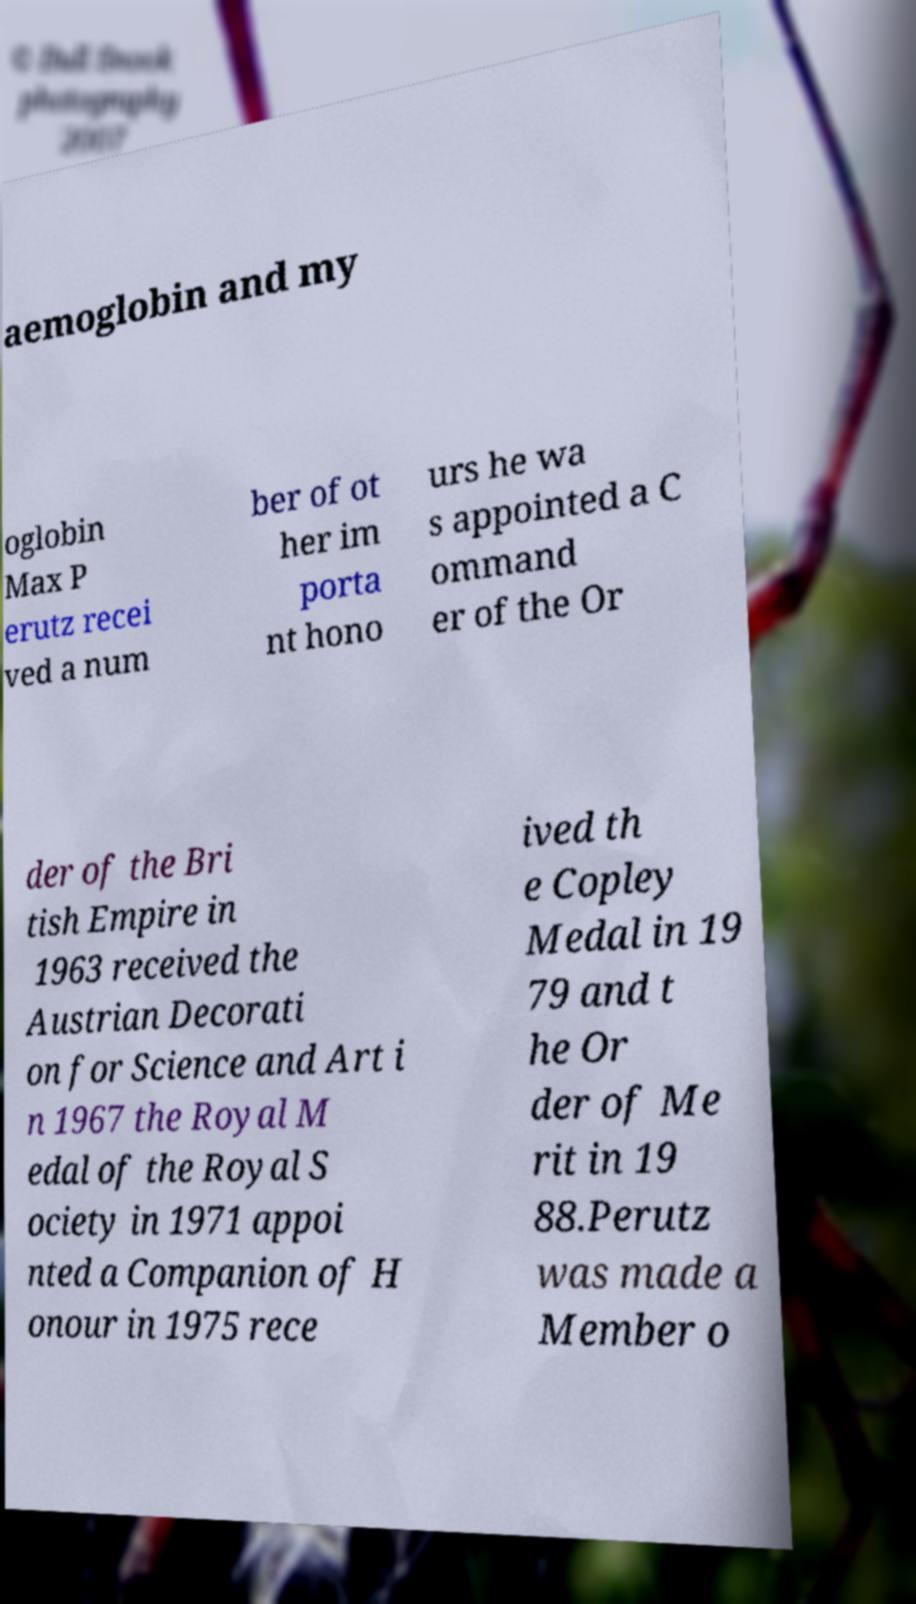Can you read and provide the text displayed in the image?This photo seems to have some interesting text. Can you extract and type it out for me? aemoglobin and my oglobin Max P erutz recei ved a num ber of ot her im porta nt hono urs he wa s appointed a C ommand er of the Or der of the Bri tish Empire in 1963 received the Austrian Decorati on for Science and Art i n 1967 the Royal M edal of the Royal S ociety in 1971 appoi nted a Companion of H onour in 1975 rece ived th e Copley Medal in 19 79 and t he Or der of Me rit in 19 88.Perutz was made a Member o 